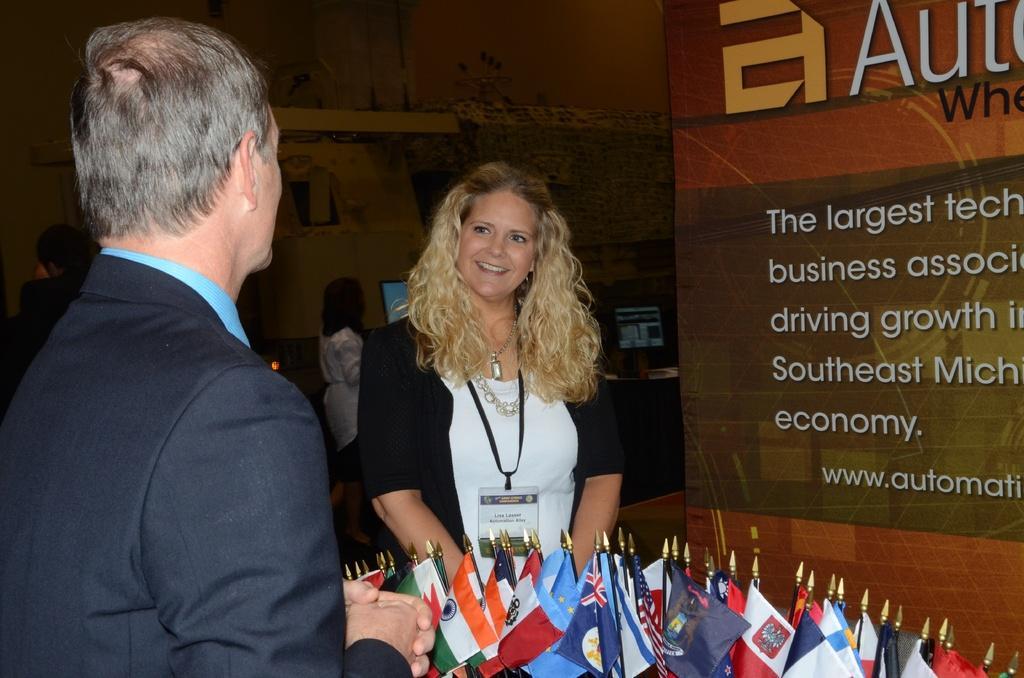How would you summarize this image in a sentence or two? In the center of the image, we can see a lady wearing id card and smiling. In the background, there are some other people and we can see monitors, flags and boards. 